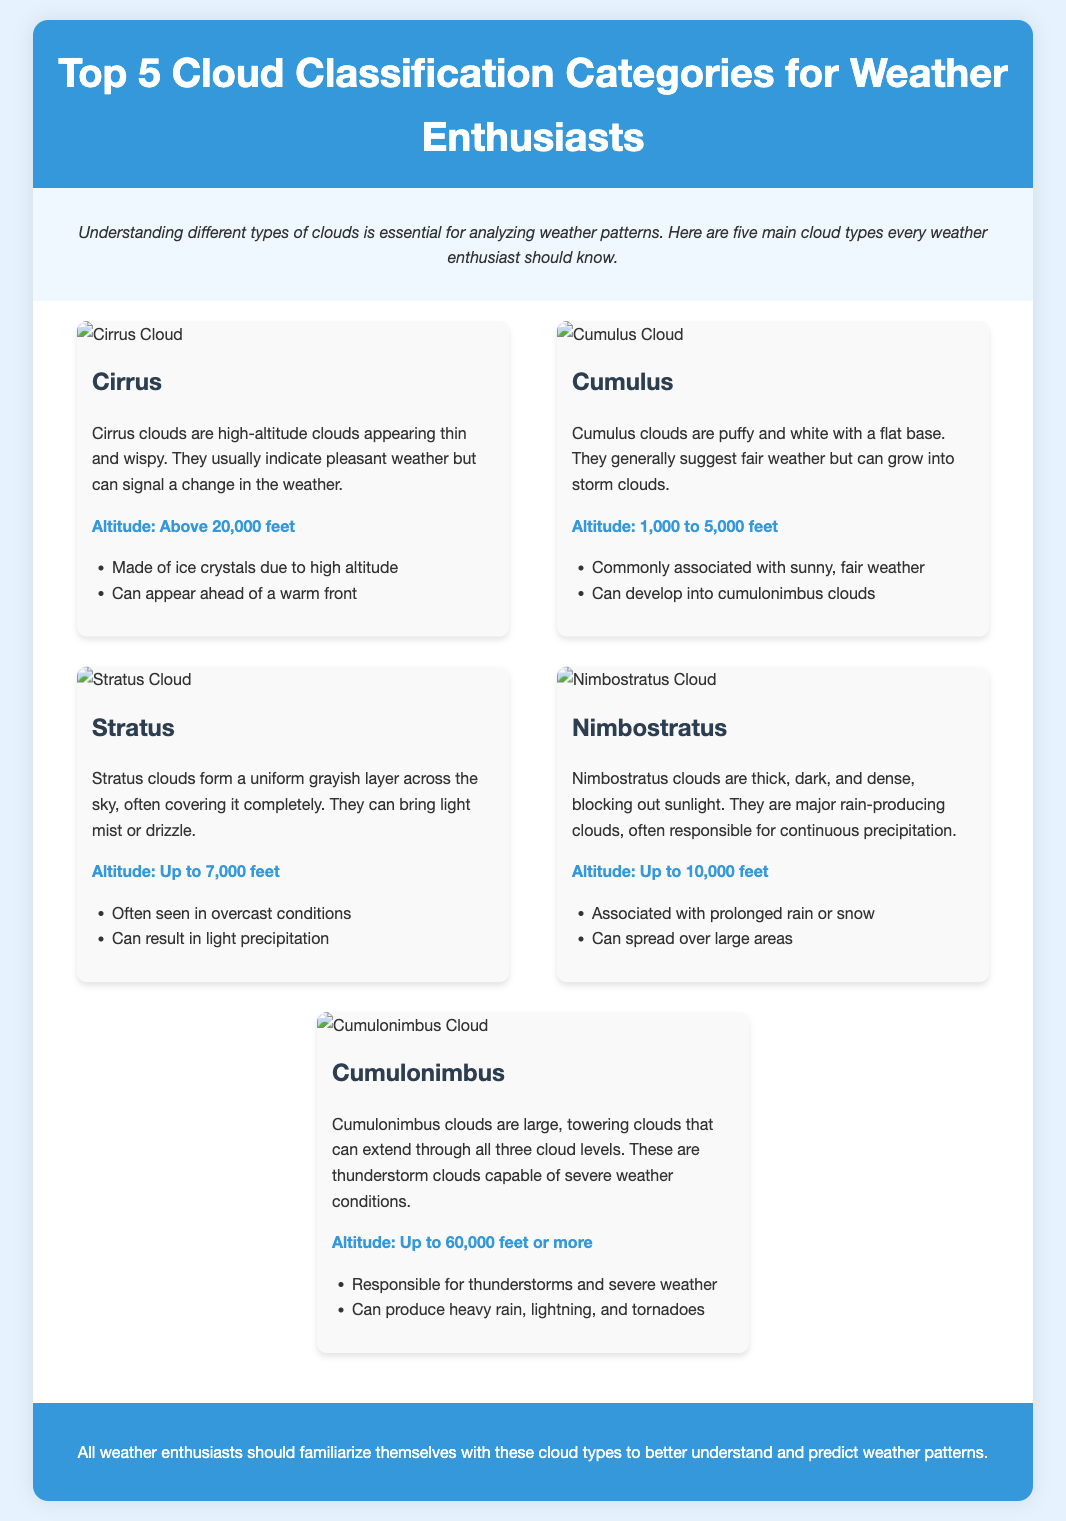What type of cloud is characterized by thin and wispy appearance? The cloud item describes Cirrus clouds as thin and wispy.
Answer: Cirrus What is the altitude range for Cumulus clouds? The document states that Cumulus clouds have an altitude of 1,000 to 5,000 feet.
Answer: 1,000 to 5,000 feet What do Stratus clouds typically bring? Stratus clouds can bring light mist or drizzle as mentioned in the document.
Answer: Light mist or drizzle Which cloud type is primarily responsible for thunderstorms? The document indicates Cumulonimbus clouds are responsible for thunderstorms.
Answer: Cumulonimbus What altitude can Nimbostratus clouds reach? Nimbostratus clouds have an altitude of up to 10,000 feet according to the document.
Answer: Up to 10,000 feet How are Cirrus clouds primarily formed? Cirrus clouds are made of ice crystals due to high altitude.
Answer: Ice crystals What do Cumulus clouds indicate about weather? Cumulus clouds generally suggest fair weather as mentioned in the description.
Answer: Fair weather What type of clouds can develop into cumulonimbus clouds? The information shows that Cumulus clouds can develop into cumulonimbus clouds.
Answer: Cumulus What color are Stratus clouds typically? The document describes Stratus clouds as grayish.
Answer: Grayish 